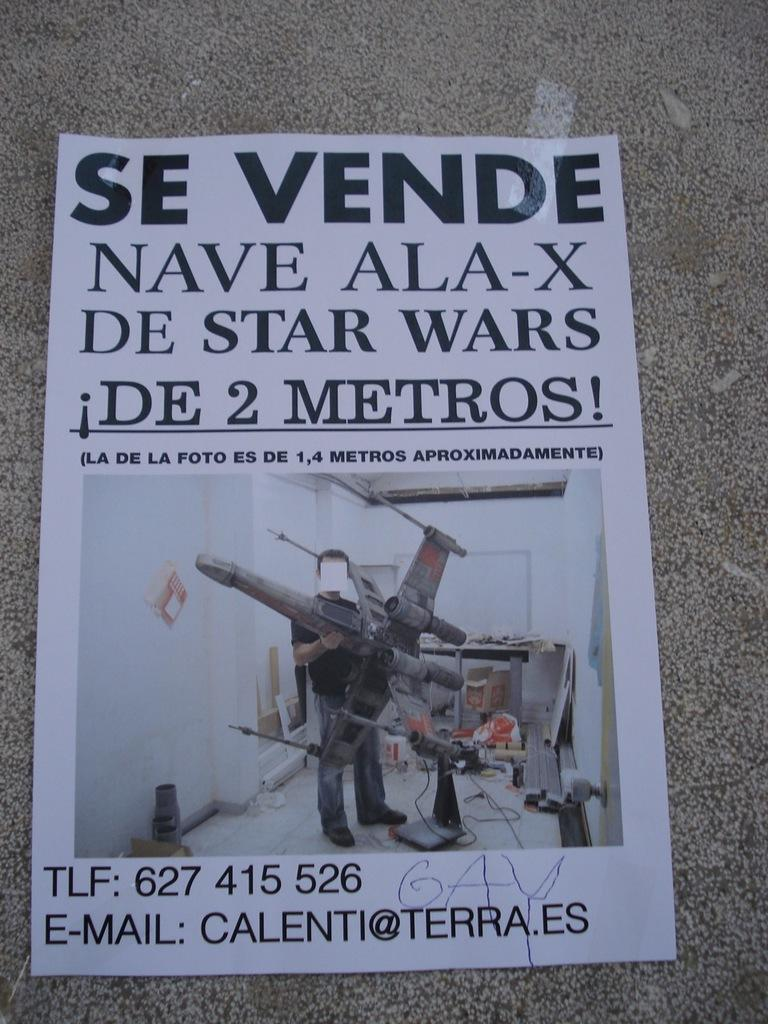Provide a one-sentence caption for the provided image. A flyer for large size Star Wars fighter wing models written in Spanish. 